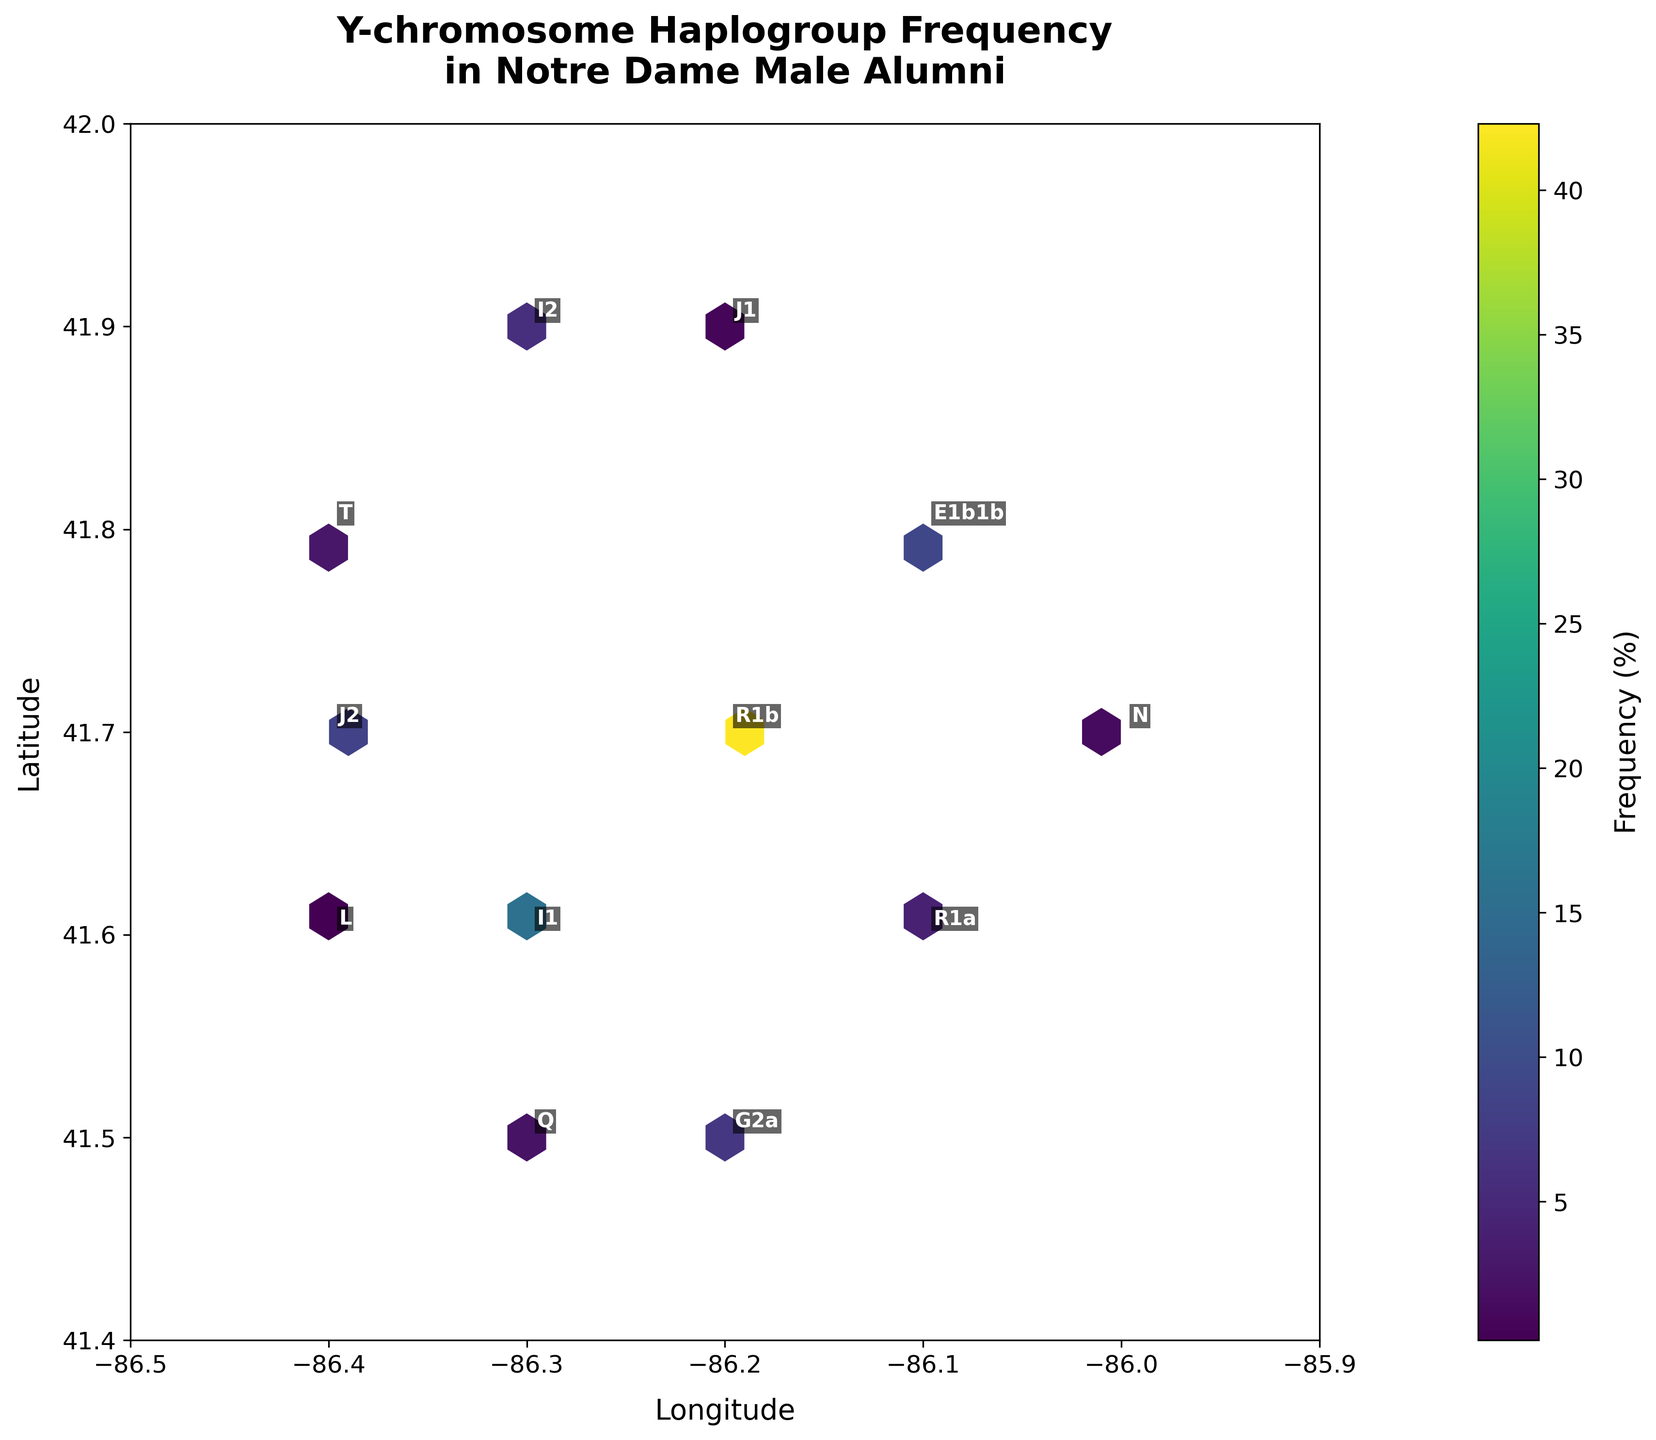What is the title of the figure? The title of the figure is prominently displayed at the top, summarizing the content of the plot.
Answer: Y-chromosome Haplogroup Frequency in Notre Dame Male Alumni What do the colors represent on the plot? The colors of the hexagons in the hexbin plot represent different frequency percentages of the Y-chromosome haplogroups. Darker colors indicate higher frequencies, and lighter colors represent lower frequencies.
Answer: Frequency (%) What range of latitude is covered in the plot? According to the y-axis labels, the plot covers latitudes from approximately 41.4 to 42.0.
Answer: 41.4 to 42.0 Which haplogroup has the highest frequency, and where is it located? The annotated text on the plot shows the haplogroup R1b with the highest frequency of 42.3%. It is located around the coordinate (41.7, -86.2).
Answer: R1b at (41.7, -86.2) How does the frequency of haplogroup J2 compare to haplogroup J1? By looking at the annotations, haplogroup J2 has a frequency of 8.5% while J1 has a frequency of 0.8%. J2 has a significantly higher frequency than J1.
Answer: J2 has higher frequency than J1 What is the combined frequency of haplogroups I1 and I2? Haplogroup I1 has a frequency of 15.7%, and I2 has 5.9%. Adding these frequencies gives a combined frequency of 15.7% + 5.9% = 21.6%.
Answer: 21.6% Which hexbin is represented by the coordinates (41.8, -86.4), and what is its frequency? The specific hexbin at these coordinates is annotated with the haplogroup T having a frequency of 2.8%.
Answer: Haplogroup T with 2.8% What does the color bar label indicate? The color bar label indicates the values that the colors on the hexbin plot are representing, which in this case is the frequency (%) of the haplogroups.
Answer: Frequency (%) If one were interested in haplogroup G2a's distribution, what coordinates should they look at, and what is its frequency? The plot annotates G2a near the coordinates (41.5, -86.2) with a frequency of 6.8%.
Answer: (41.5, -86.2) with 6.8% What is the frequency difference between haplogroup R1a and Q? From the annotations, haplogroup R1a has a frequency of 4.1% and Q has 2.3%. The difference is 4.1% - 2.3% = 1.8%.
Answer: 1.8% 